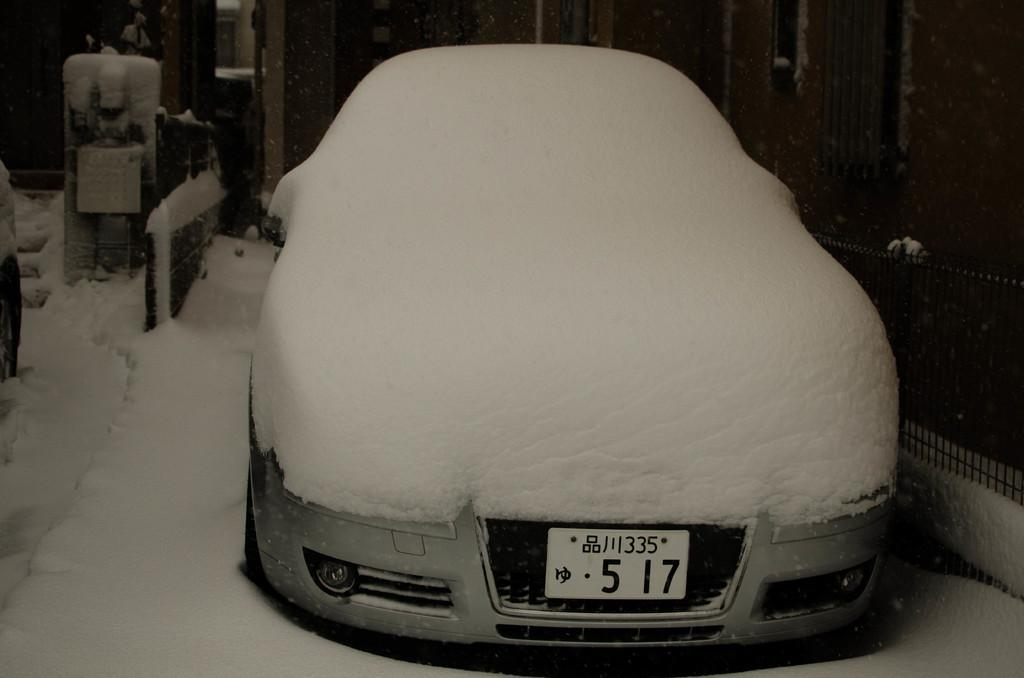What is the main subject of the image? The main subject of the image is a car. What is covering the car in the image? The car is covered with snow. Can you describe any other objects or structures in the image? Yes, there is a railing in the image. What is visible at the bottom of the image? Snow is visible at the bottom of the image. What type of chin can be seen on the car in the image? There is no chin present on the car in the image; it is a vehicle, not a person or animal. 